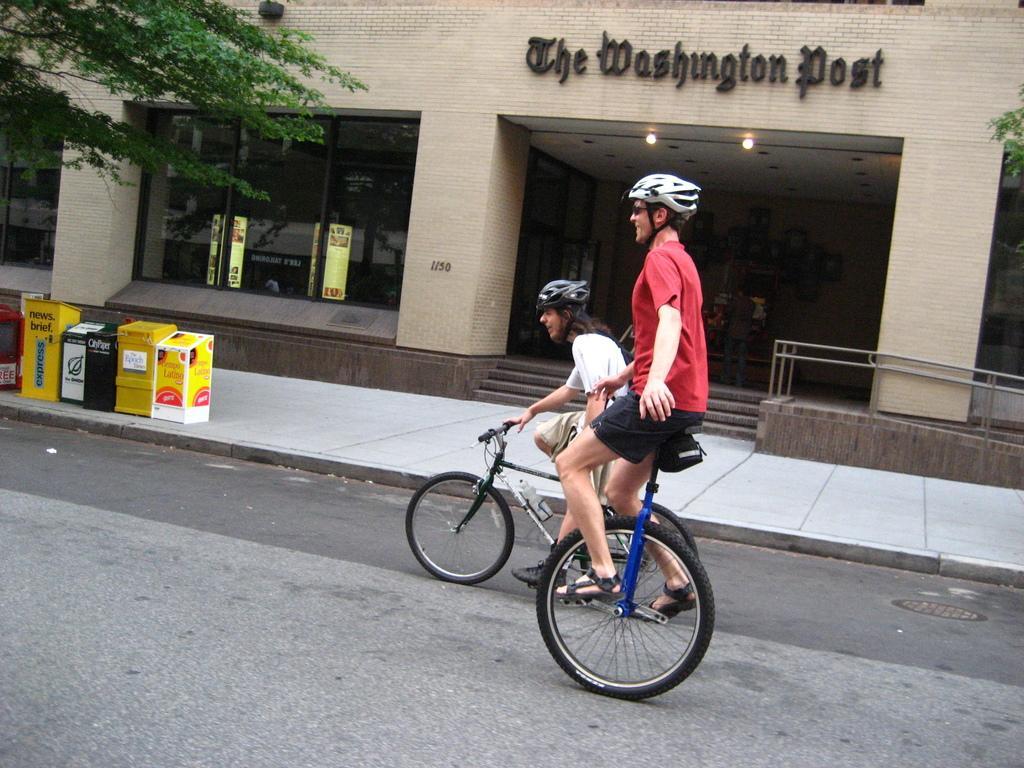How would you summarize this image in a sentence or two? This is the picture of a place where we have two people wearing helmets and riding the cycles and to the side there is a building on which there are some things written and to the side we can see a tree and some things on the floor. 